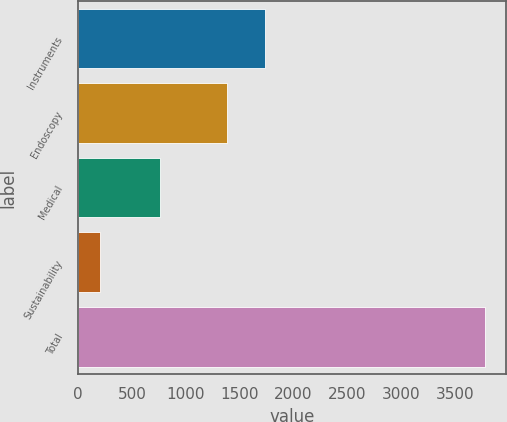<chart> <loc_0><loc_0><loc_500><loc_500><bar_chart><fcel>Instruments<fcel>Endoscopy<fcel>Medical<fcel>Sustainability<fcel>Total<nl><fcel>1739.2<fcel>1382<fcel>766<fcel>209<fcel>3781<nl></chart> 